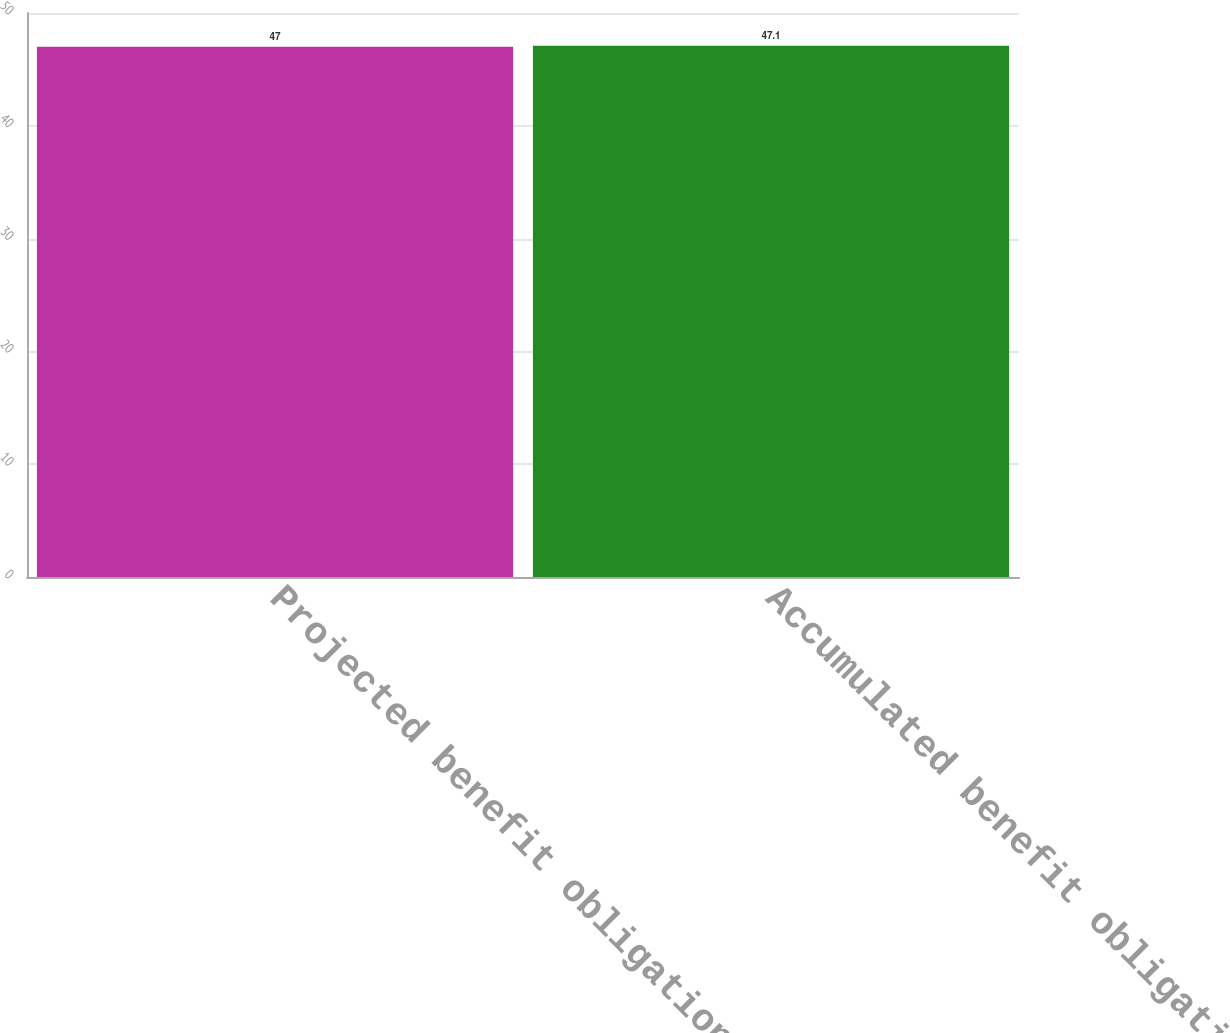<chart> <loc_0><loc_0><loc_500><loc_500><bar_chart><fcel>Projected benefit obligation<fcel>Accumulated benefit obligation<nl><fcel>47<fcel>47.1<nl></chart> 